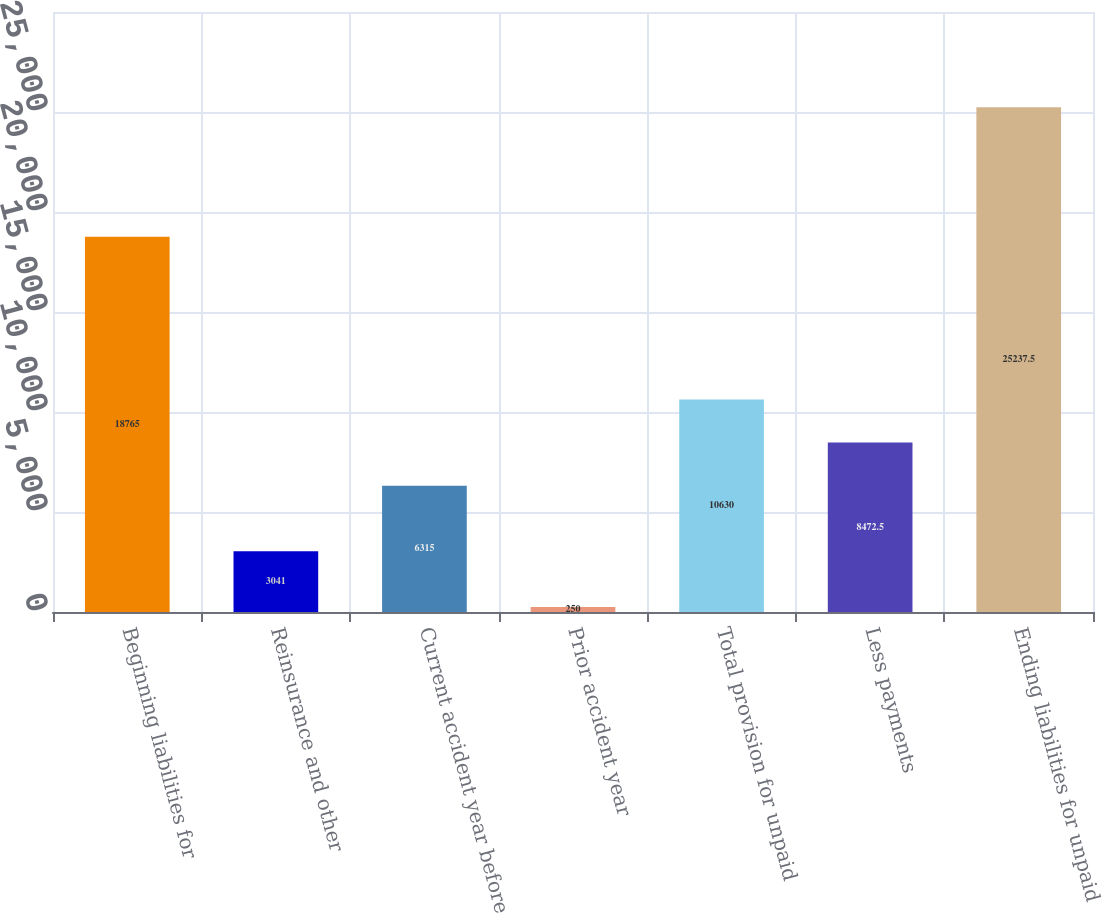Convert chart. <chart><loc_0><loc_0><loc_500><loc_500><bar_chart><fcel>Beginning liabilities for<fcel>Reinsurance and other<fcel>Current accident year before<fcel>Prior accident year<fcel>Total provision for unpaid<fcel>Less payments<fcel>Ending liabilities for unpaid<nl><fcel>18765<fcel>3041<fcel>6315<fcel>250<fcel>10630<fcel>8472.5<fcel>25237.5<nl></chart> 